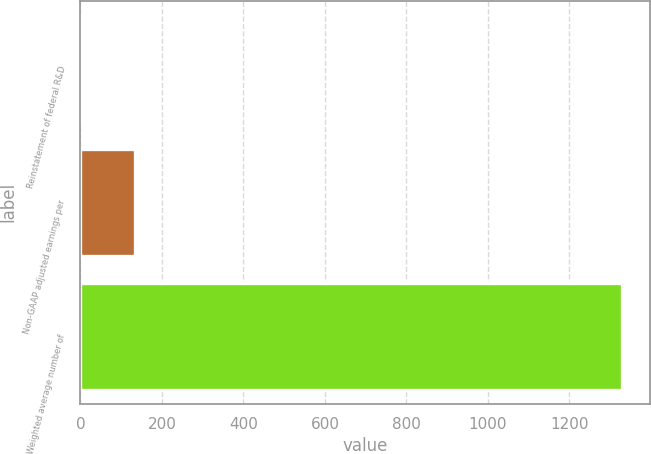Convert chart to OTSL. <chart><loc_0><loc_0><loc_500><loc_500><bar_chart><fcel>Reinstatement of federal R&D<fcel>Non-GAAP adjusted earnings per<fcel>Weighted average number of<nl><fcel>0.16<fcel>133.14<fcel>1330<nl></chart> 